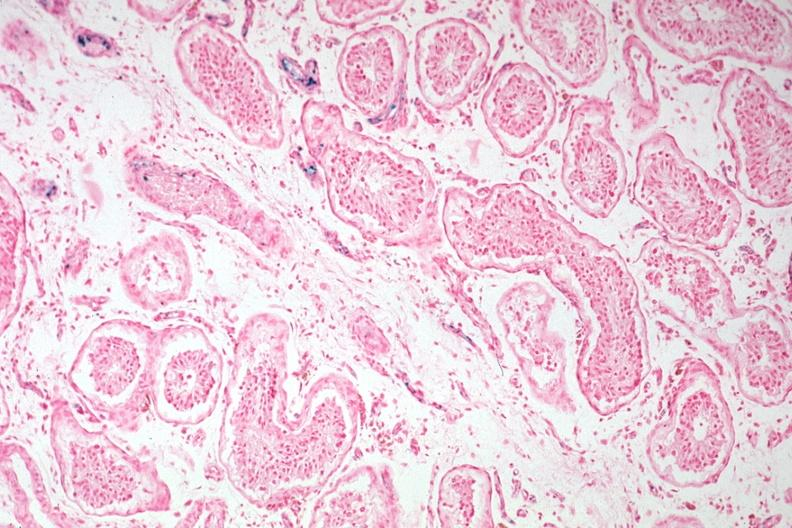does iron stain tubular atrophy and interstitial iron deposits?
Answer the question using a single word or phrase. Yes 